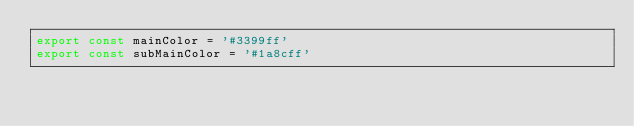Convert code to text. <code><loc_0><loc_0><loc_500><loc_500><_TypeScript_>export const mainColor = '#3399ff'
export const subMainColor = '#1a8cff'</code> 